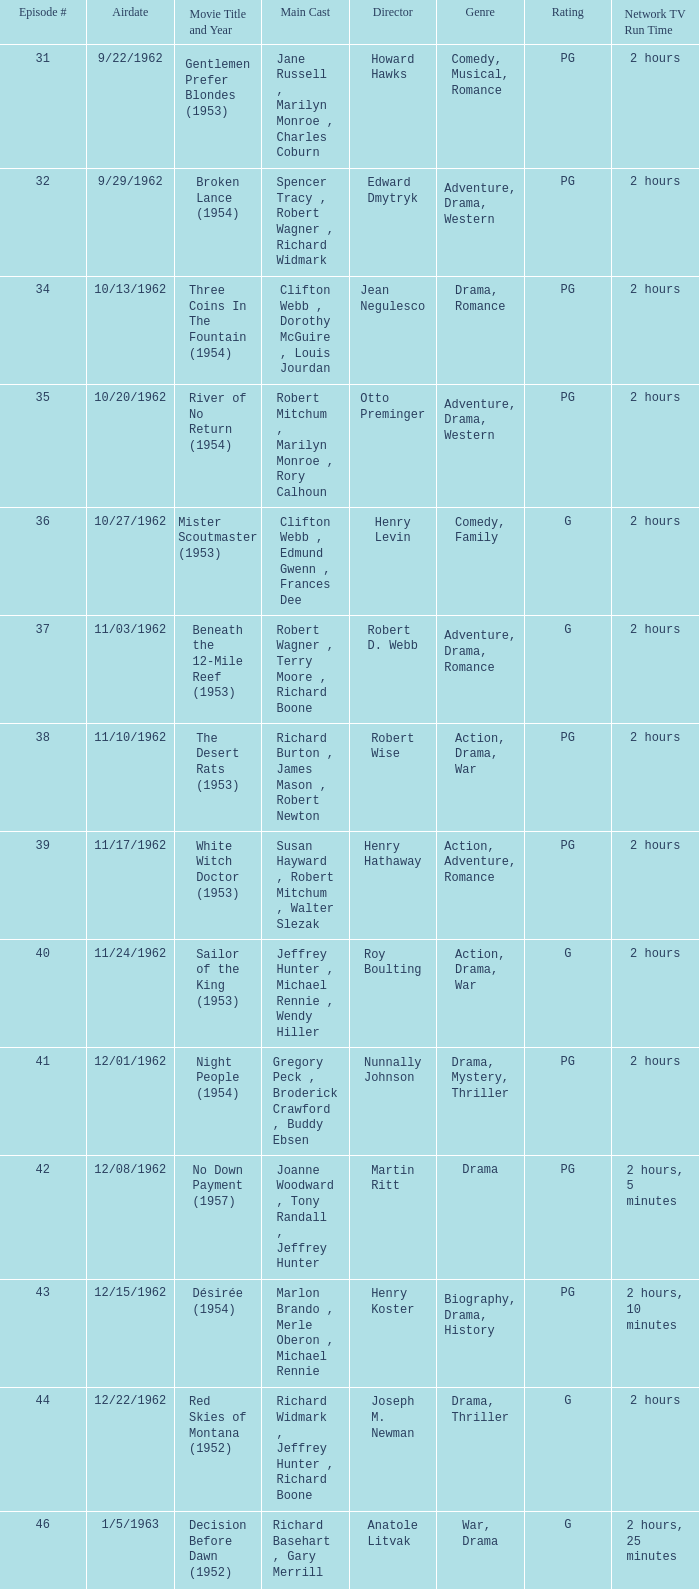Can you parse all the data within this table? {'header': ['Episode #', 'Airdate', 'Movie Title and Year', 'Main Cast', 'Director', 'Genre', 'Rating', 'Network TV Run Time'], 'rows': [['31', '9/22/1962', 'Gentlemen Prefer Blondes (1953)', 'Jane Russell , Marilyn Monroe , Charles Coburn', 'Howard Hawks', 'Comedy, Musical, Romance', 'PG', '2 hours'], ['32', '9/29/1962', 'Broken Lance (1954)', 'Spencer Tracy , Robert Wagner , Richard Widmark', 'Edward Dmytryk', 'Adventure, Drama, Western', 'PG', '2 hours'], ['34', '10/13/1962', 'Three Coins In The Fountain (1954)', 'Clifton Webb , Dorothy McGuire , Louis Jourdan', 'Jean Negulesco', 'Drama, Romance', 'PG', '2 hours'], ['35', '10/20/1962', 'River of No Return (1954)', 'Robert Mitchum , Marilyn Monroe , Rory Calhoun', 'Otto Preminger', 'Adventure, Drama, Western', 'PG', '2 hours'], ['36', '10/27/1962', 'Mister Scoutmaster (1953)', 'Clifton Webb , Edmund Gwenn , Frances Dee', 'Henry Levin', 'Comedy, Family', 'G', '2 hours'], ['37', '11/03/1962', 'Beneath the 12-Mile Reef (1953)', 'Robert Wagner , Terry Moore , Richard Boone', 'Robert D. Webb', 'Adventure, Drama, Romance', 'G', '2 hours'], ['38', '11/10/1962', 'The Desert Rats (1953)', 'Richard Burton , James Mason , Robert Newton', 'Robert Wise', 'Action, Drama, War', 'PG', '2 hours'], ['39', '11/17/1962', 'White Witch Doctor (1953)', 'Susan Hayward , Robert Mitchum , Walter Slezak', 'Henry Hathaway', 'Action, Adventure, Romance', 'PG', '2 hours'], ['40', '11/24/1962', 'Sailor of the King (1953)', 'Jeffrey Hunter , Michael Rennie , Wendy Hiller', 'Roy Boulting', 'Action, Drama, War', 'G', '2 hours'], ['41', '12/01/1962', 'Night People (1954)', 'Gregory Peck , Broderick Crawford , Buddy Ebsen', 'Nunnally Johnson', 'Drama, Mystery, Thriller', 'PG', '2 hours'], ['42', '12/08/1962', 'No Down Payment (1957)', 'Joanne Woodward , Tony Randall , Jeffrey Hunter', 'Martin Ritt', 'Drama', 'PG', '2 hours, 5 minutes'], ['43', '12/15/1962', 'Désirée (1954)', 'Marlon Brando , Merle Oberon , Michael Rennie', 'Henry Koster', 'Biography, Drama, History', 'PG', '2 hours, 10 minutes'], ['44', '12/22/1962', 'Red Skies of Montana (1952)', 'Richard Widmark , Jeffrey Hunter , Richard Boone', 'Joseph M. Newman', 'Drama, Thriller', 'G', '2 hours'], ['46', '1/5/1963', 'Decision Before Dawn (1952)', 'Richard Basehart , Gary Merrill , Hildegard Neff', 'Anatole Litvak', 'War, Drama', 'G', '2 hours, 25 minutes'], ['47', '1/12/1963', 'The Sun Also Rises (1957)', 'Tyrone Power , Ava Gardner , Errol Flynn', 'Henry King', 'Drama, Romance', 'PG', '2 hours, 35 minutes'], ['48', '1/19/1963', "Woman's World (1954)", 'Van Heflin , Lauren Bacall , Clifton Webb', 'Jean Negulesco', 'Drama, Comedy', 'G', '2 hours'], ['49', '1/26/1963', 'Deadline - U.S.A. (1952)', 'Humphrey Bogart , Kim Hunter , Ed Begley', 'Richard Brooks', 'Crime, Drama, Film-Noir', 'PG', '2 hours'], ['50', '2/2/1963', 'Niagara (1953)', 'Marilyn Monroe , Joseph Cotten , Jean Peters', 'Henry Hathaway', 'Film-Noir, Thriller', 'PG', '2 hours'], ['51', '2/9/1963', 'Kangaroo (1952)', "Maureen O'Hara , Peter Lawford , Richard Boone", 'Lewis Milestone', 'Adventure, Drama, History', 'G', '2 hours'], ['52', '2/16/1963', 'The Long Hot Summer (1958)', 'Paul Newman , Joanne Woodward , Orson Wells', 'Martin Ritt', 'Drama, Romance', 'PG', '2 hours, 15 minutes'], ['53', '2/23/1963', "The President's Lady (1953)", 'Susan Hayward , Charlton Heston , John McIntire', 'Henry Levin', 'Biography, Drama, History', 'PG', '2 hours'], ['54', '3/2/1963', 'The Roots of Heaven (1958)', 'Errol Flynn , Juliette Greco , Eddie Albert', 'John Huston', 'Adventure, Drama', 'G', '2 hours, 25 minutes'], ['55', '3/9/1963', 'In Love and War (1958)', 'Robert Wagner , Hope Lange , Jeffrey Hunter', 'Philip Dunne', 'Drama, Romance, War', 'PG', '2 hours, 10 minutes'], ['56', '3/16/1963', 'A Certain Smile (1958)', 'Rossano Brazzi , Joan Fontaine , Johnny Mathis', 'Jean Negulesco', 'Drama, Romance', 'PG', '2 hours, 5 minutes'], ['57', '3/23/1963', 'Fraulein (1958)', 'Dana Wynter , Mel Ferrer , Theodore Bikel', 'Henry Koster', 'Drama, Romance, War', 'PG', '2 hours'], ['59', '4/6/1963', 'Night and the City (1950)', 'Richard Widmark , Gene Tierney , Herbert Lom', 'Jules Dassin', 'Crime, Film-Noir, Sport', 'G', '2 hours']]} Who was the cast on the 3/23/1963 episode? Dana Wynter , Mel Ferrer , Theodore Bikel. 